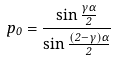Convert formula to latex. <formula><loc_0><loc_0><loc_500><loc_500>p _ { 0 } = \frac { \sin \frac { \gamma \alpha } { 2 } } { \sin \frac { ( 2 - \gamma ) \alpha } { 2 } }</formula> 